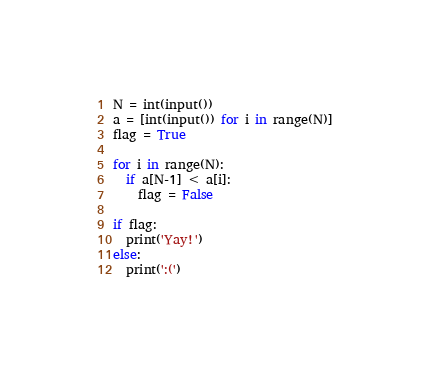Convert code to text. <code><loc_0><loc_0><loc_500><loc_500><_Python_>N = int(input())
a = [int(input()) for i in range(N)]
flag = True

for i in range(N):
  if a[N-1] < a[i]:
    flag = False

if flag:
  print('Yay!')
else:
  print(':(')
</code> 